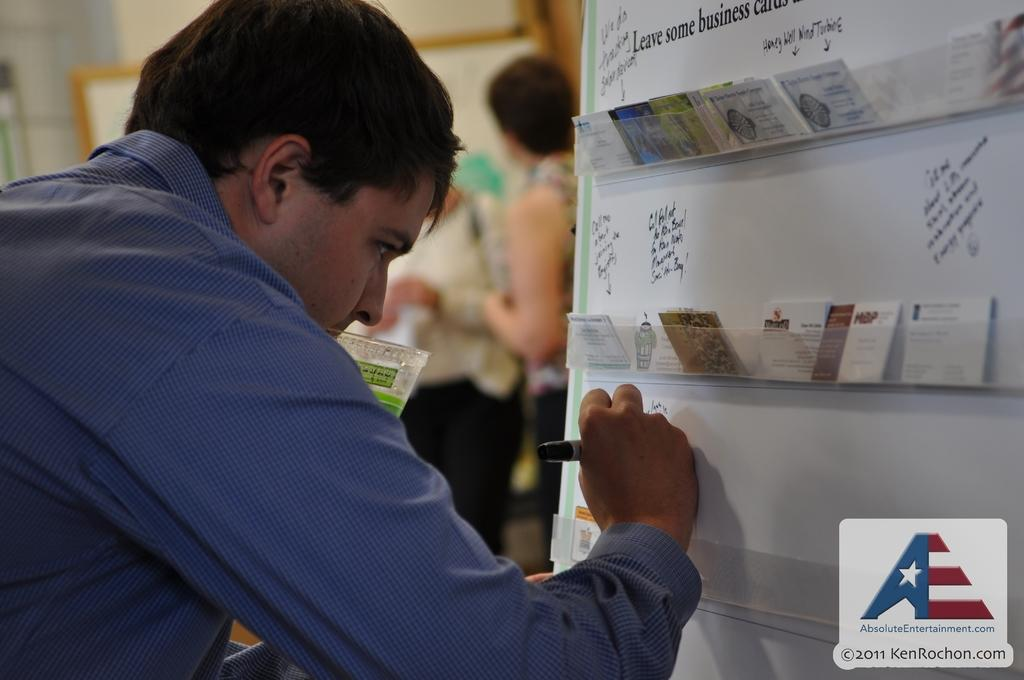<image>
Render a clear and concise summary of the photo. A man writes on a whiteboard that says "Leave some business cards...". 